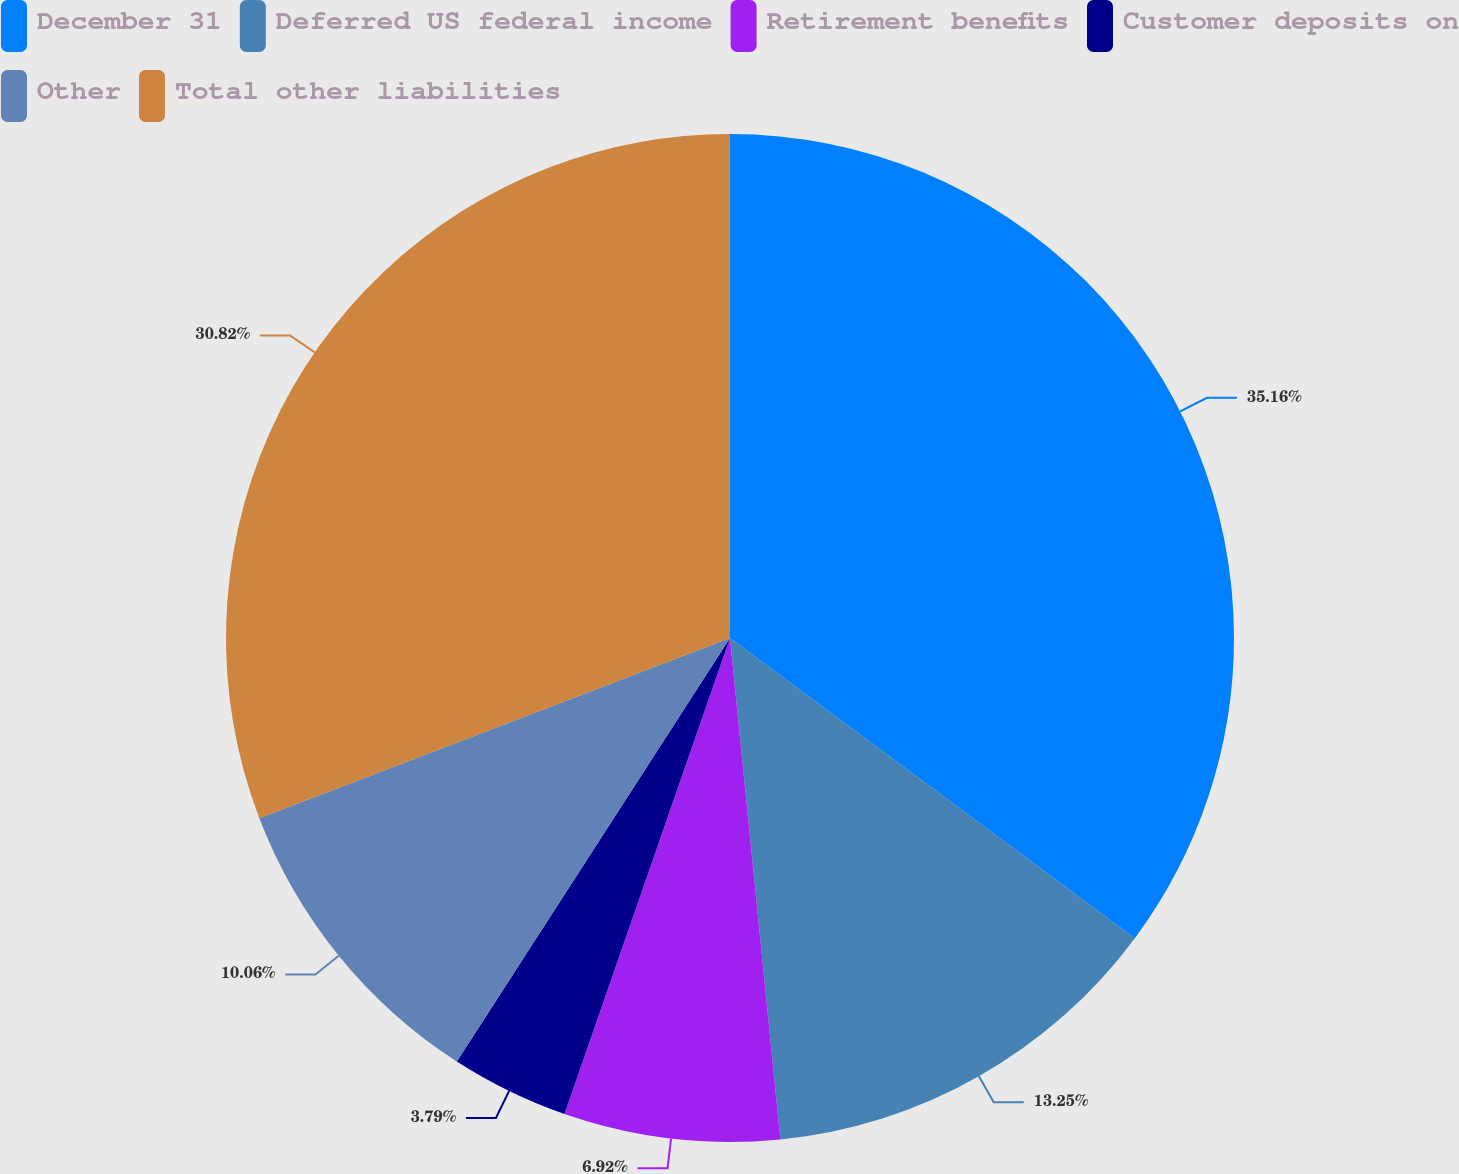Convert chart to OTSL. <chart><loc_0><loc_0><loc_500><loc_500><pie_chart><fcel>December 31<fcel>Deferred US federal income<fcel>Retirement benefits<fcel>Customer deposits on<fcel>Other<fcel>Total other liabilities<nl><fcel>35.15%<fcel>13.25%<fcel>6.92%<fcel>3.79%<fcel>10.06%<fcel>30.82%<nl></chart> 